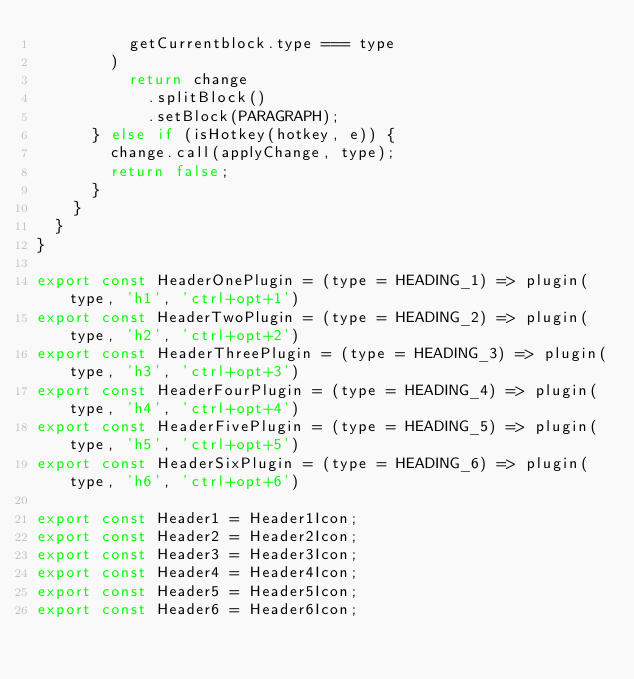<code> <loc_0><loc_0><loc_500><loc_500><_JavaScript_>          getCurrentblock.type === type
        )
          return change
            .splitBlock()
            .setBlock(PARAGRAPH);
      } else if (isHotkey(hotkey, e)) {
        change.call(applyChange, type);
        return false;
      }
    }
  }
}

export const HeaderOnePlugin = (type = HEADING_1) => plugin(type, 'h1', 'ctrl+opt+1')
export const HeaderTwoPlugin = (type = HEADING_2) => plugin(type, 'h2', 'ctrl+opt+2')
export const HeaderThreePlugin = (type = HEADING_3) => plugin(type, 'h3', 'ctrl+opt+3')
export const HeaderFourPlugin = (type = HEADING_4) => plugin(type, 'h4', 'ctrl+opt+4')
export const HeaderFivePlugin = (type = HEADING_5) => plugin(type, 'h5', 'ctrl+opt+5')
export const HeaderSixPlugin = (type = HEADING_6) => plugin(type, 'h6', 'ctrl+opt+6')

export const Header1 = Header1Icon;
export const Header2 = Header2Icon;
export const Header3 = Header3Icon;
export const Header4 = Header4Icon;
export const Header5 = Header5Icon;
export const Header6 = Header6Icon;
</code> 